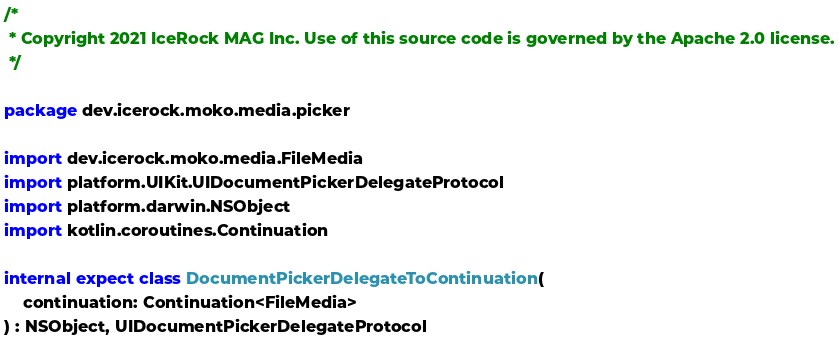<code> <loc_0><loc_0><loc_500><loc_500><_Kotlin_>/*
 * Copyright 2021 IceRock MAG Inc. Use of this source code is governed by the Apache 2.0 license.
 */

package dev.icerock.moko.media.picker

import dev.icerock.moko.media.FileMedia
import platform.UIKit.UIDocumentPickerDelegateProtocol
import platform.darwin.NSObject
import kotlin.coroutines.Continuation

internal expect class DocumentPickerDelegateToContinuation(
    continuation: Continuation<FileMedia>
) : NSObject, UIDocumentPickerDelegateProtocol
</code> 